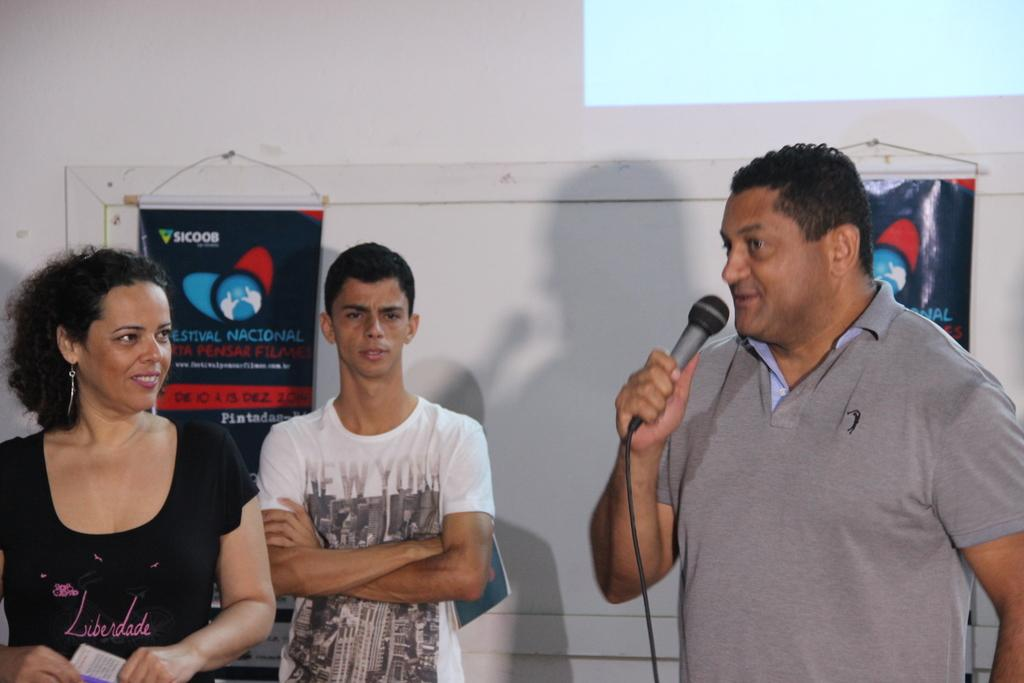What are the people in the image doing? There are persons standing in front of the wall, with one person holding a mic and another holding a book. What is attached to the wall in the image? There is a banner attached to the wall in the image. Can you see any pump, worm, or nest in the image? No, there are no pumps, worms, or nests visible in the image. 